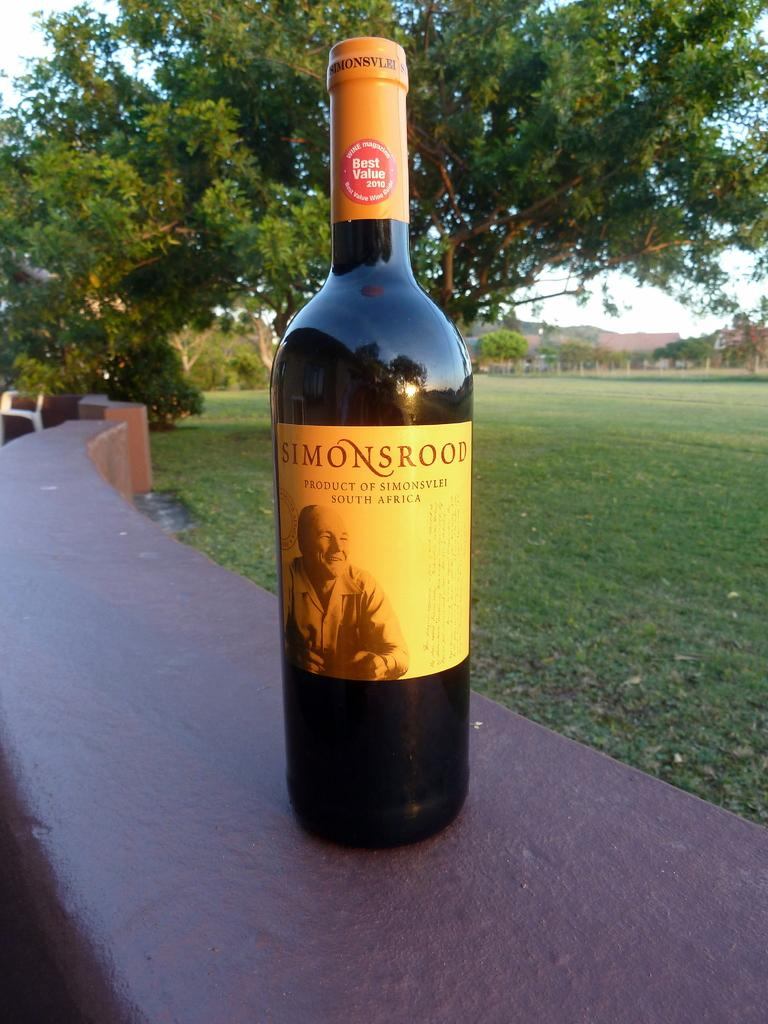<image>
Give a short and clear explanation of the subsequent image. Bottle of alcohol named Simonsrood outdoors on a table. 